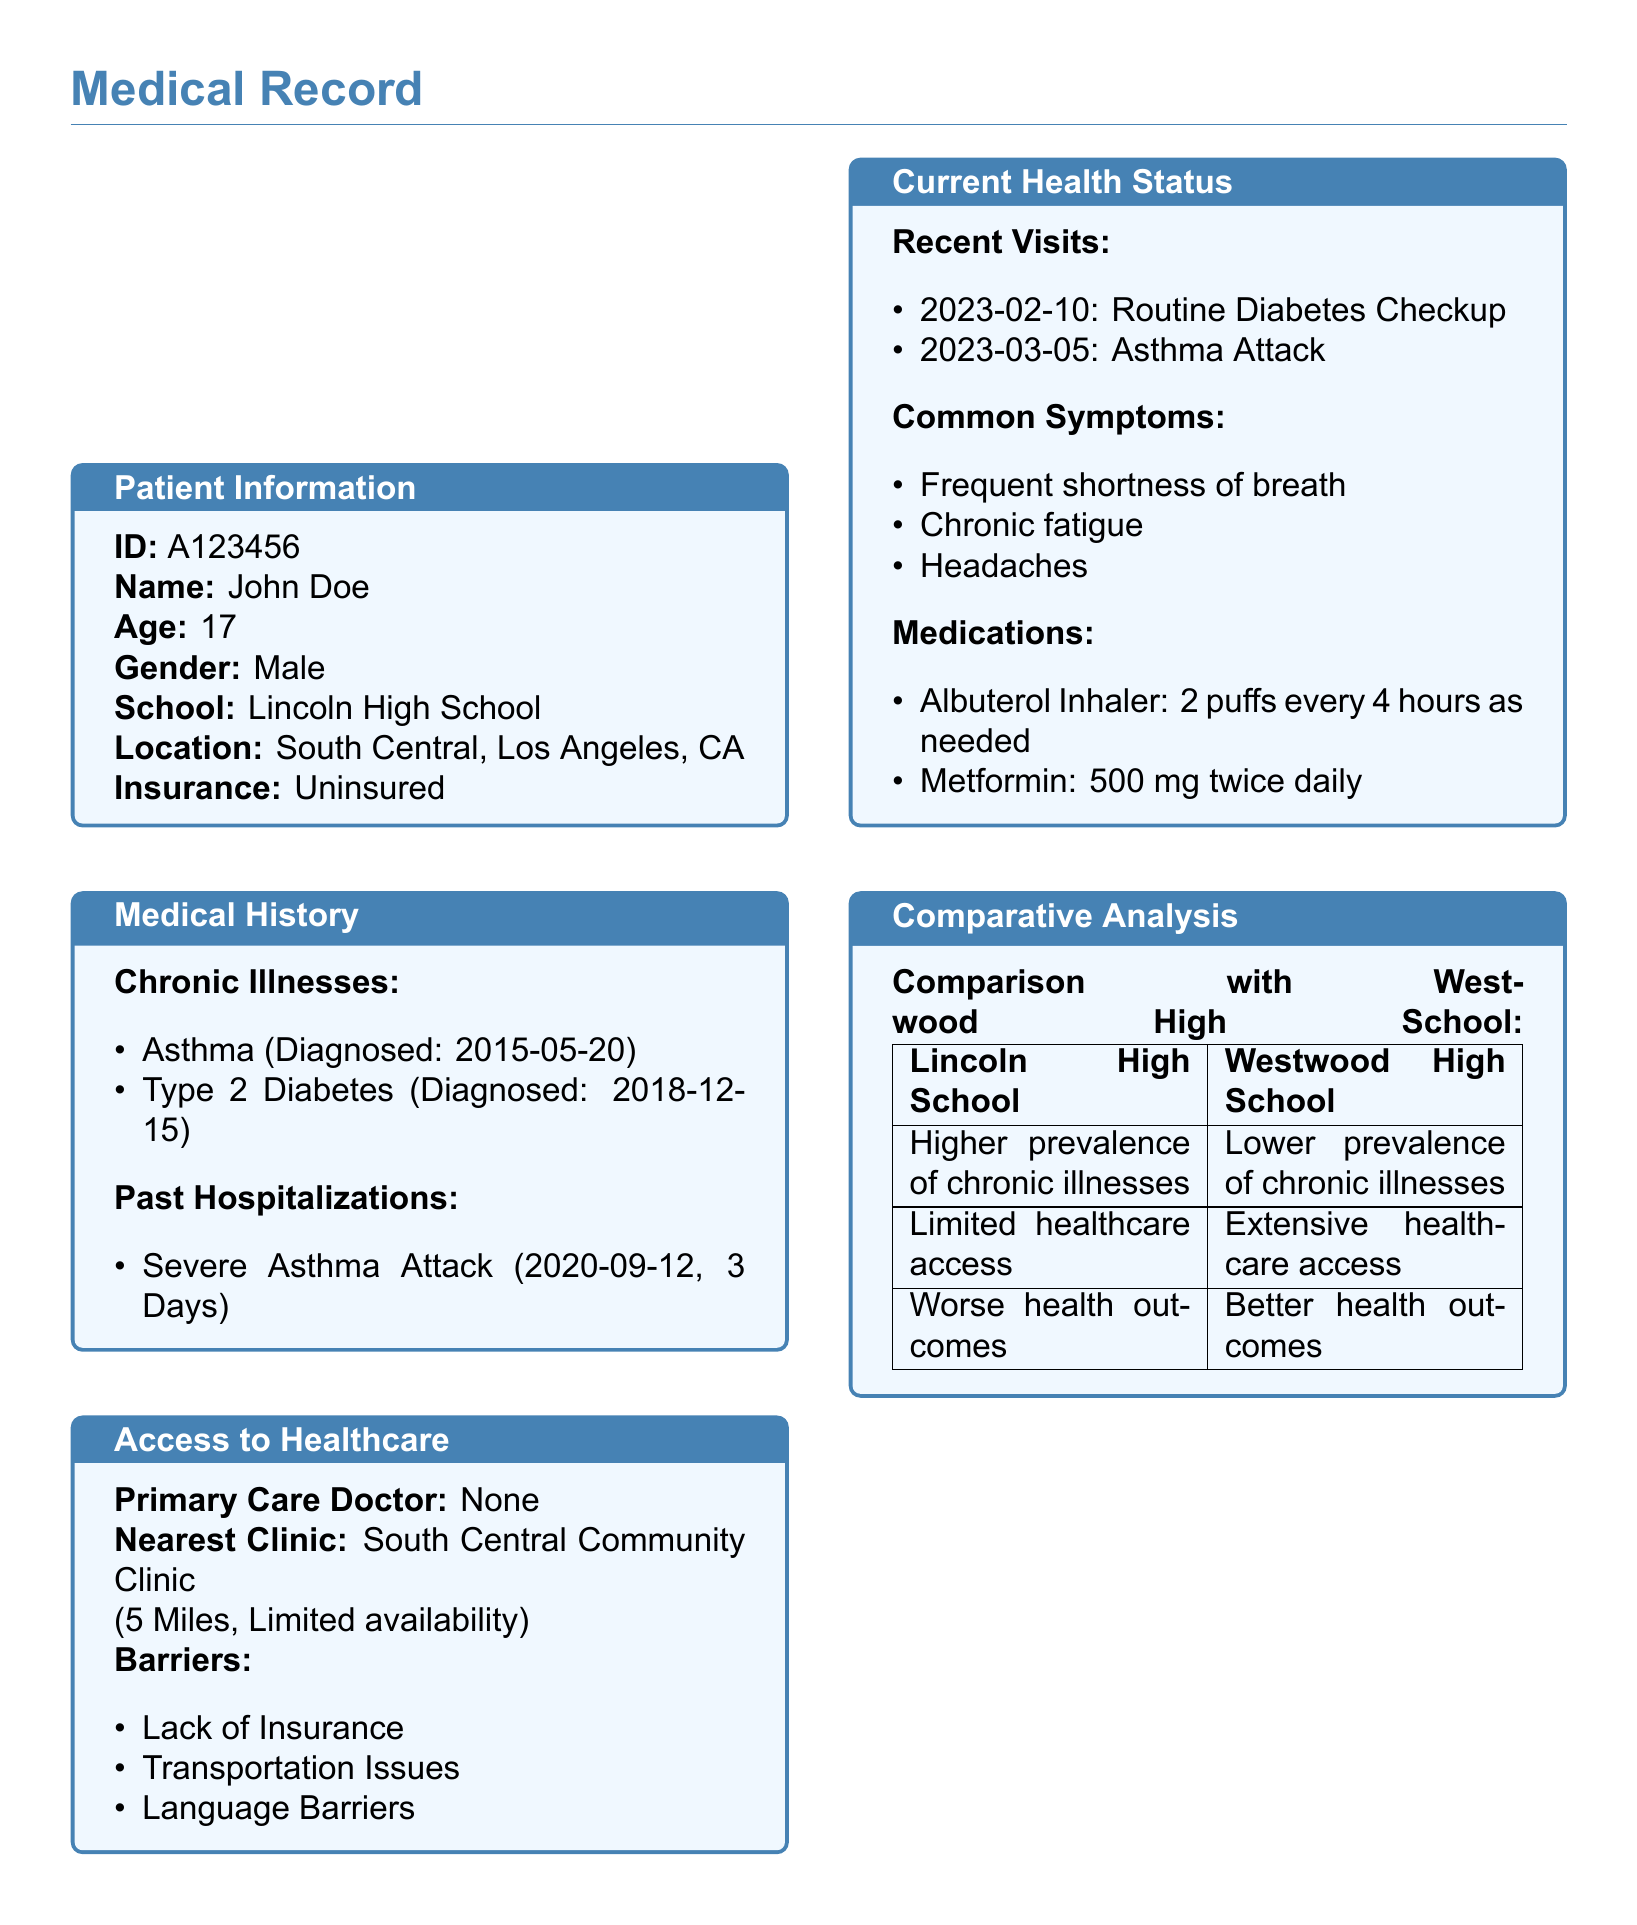What is the patient's name? The patient's name is explicitly stated in the patient information section of the document.
Answer: John Doe What are the patient's chronic illnesses? The chronic illnesses are detailed in the medical history section, listing conditions that the patient has been diagnosed with.
Answer: Asthma, Type 2 Diabetes When was the patient diagnosed with Type 2 Diabetes? The diagnosis date for Type 2 Diabetes is recorded in the medical history section.
Answer: 2018-12-15 What barriers to healthcare access does the patient face? The document lists various barriers in the access to healthcare section.
Answer: Lack of Insurance, Transportation Issues, Language Barriers How does Lincoln High School's health outcomes compare to Westwood High School? The comparative analysis section provides a direct comparison of health outcomes between the two schools.
Answer: Worse health outcomes What type of medication is the patient using for Asthma? The current health status section specifies the medications the patient is taking for asthma.
Answer: Albuterol Inhaler How far is the nearest clinic from the patient? The distance to the nearest clinic is provided under the access to healthcare section.
Answer: 5 Miles How many days was the patient hospitalized for the severe asthma attack? The duration of the hospitalization for the asthma attack is noted in the medical history section.
Answer: 3 Days What is the insurance status of the patient? The insurance status is clearly indicated in the patient information section of the document.
Answer: Uninsured 